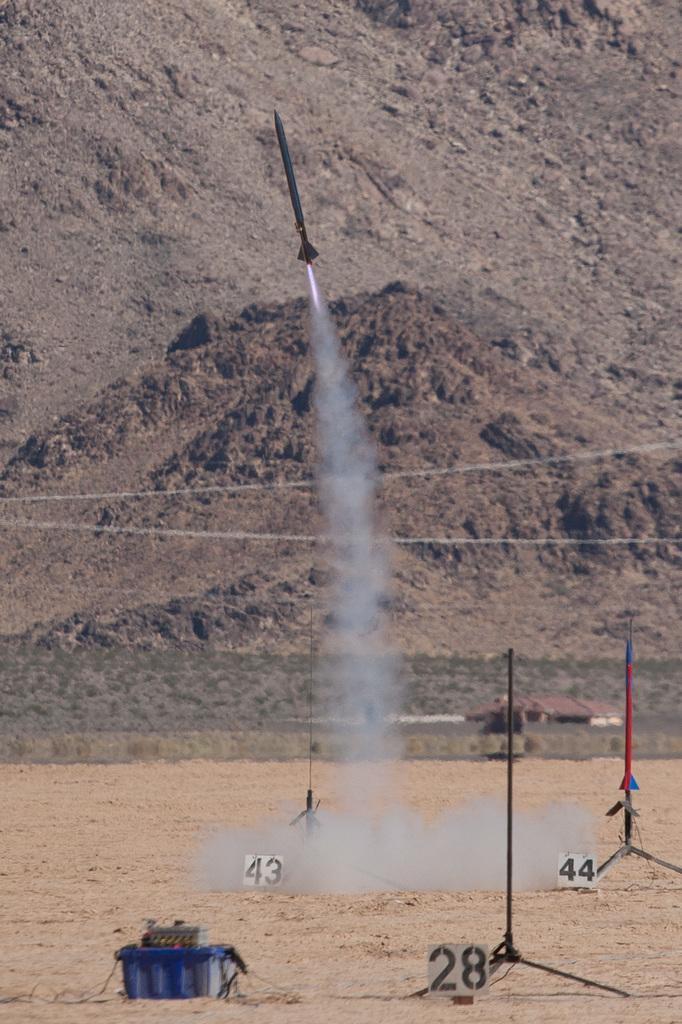Can you describe this image briefly? In this image we can see a rocket flying. There is smoke. Also there are stands with numbers. On the ground there is a box. In the back there is a hill. 